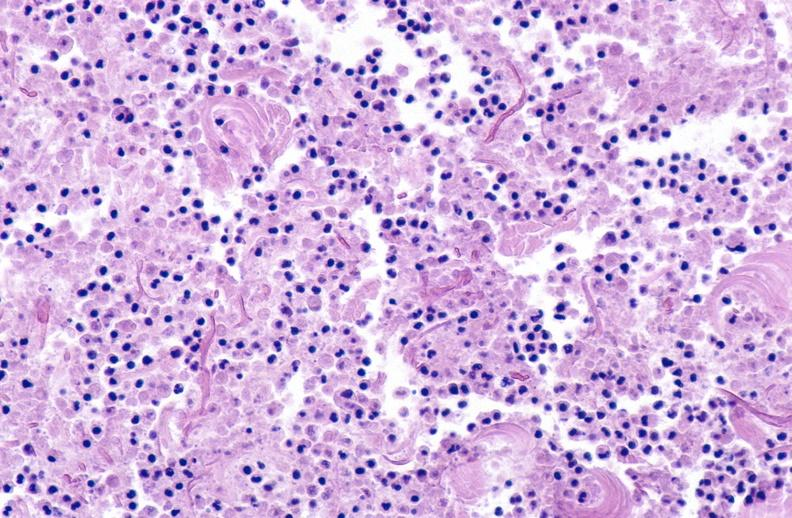where is this?
Answer the question using a single word or phrase. Skin 